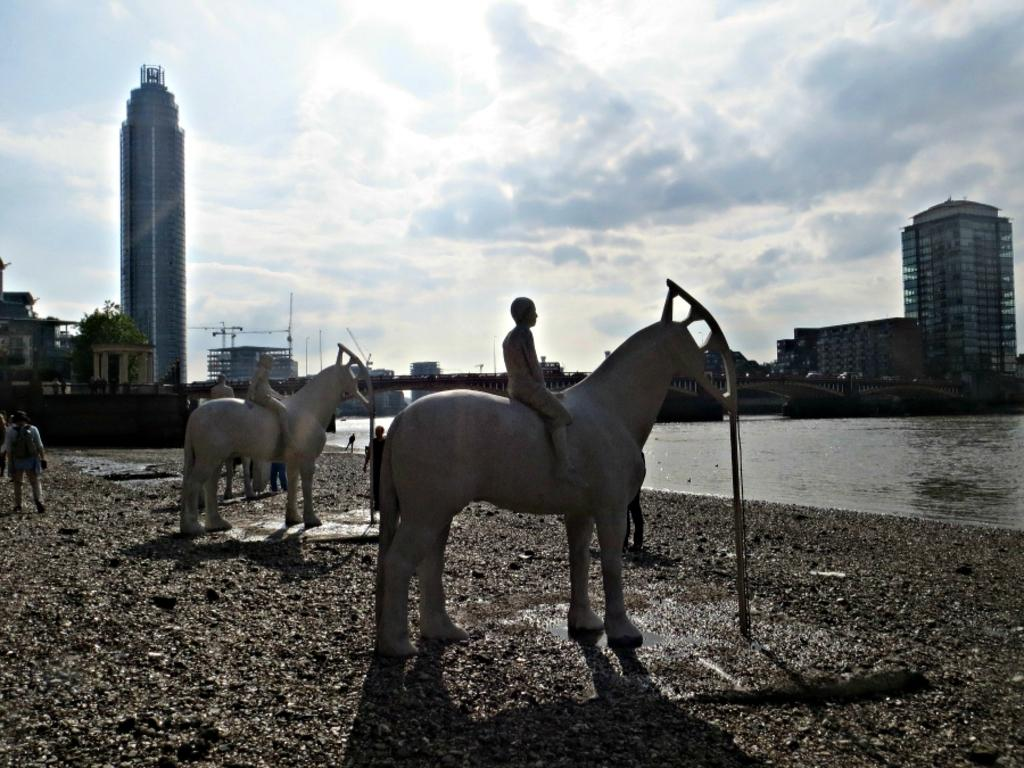What can be seen in the image that represents people and horses? There are statues of two people sitting on horses in the image. Where are the statues located? The statues are on the ground. What can be seen in the background of the image? There are people, water, buildings, trees, and the sky visible in the background of the image. What type of nose can be seen on the property in the image? There is no nose or property present in the image; it features statues of people sitting on horses and various elements in the background. What is the rate of expansion of the water in the image? There is no indication of the water expanding in the image, as it is a static representation of the scene. 